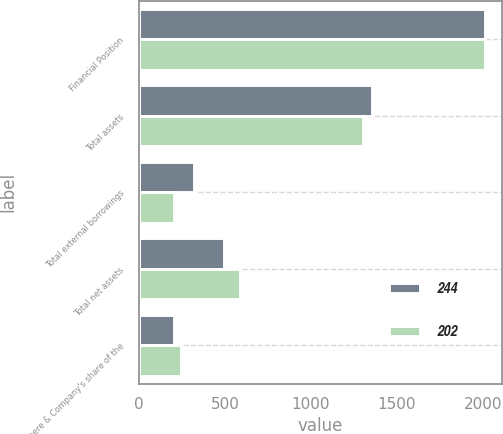Convert chart. <chart><loc_0><loc_0><loc_500><loc_500><stacked_bar_chart><ecel><fcel>Financial Position<fcel>Total assets<fcel>Total external borrowings<fcel>Total net assets<fcel>Deere & Company's share of the<nl><fcel>244<fcel>2011<fcel>1357<fcel>321<fcel>495<fcel>202<nl><fcel>202<fcel>2010<fcel>1300<fcel>201<fcel>584<fcel>244<nl></chart> 